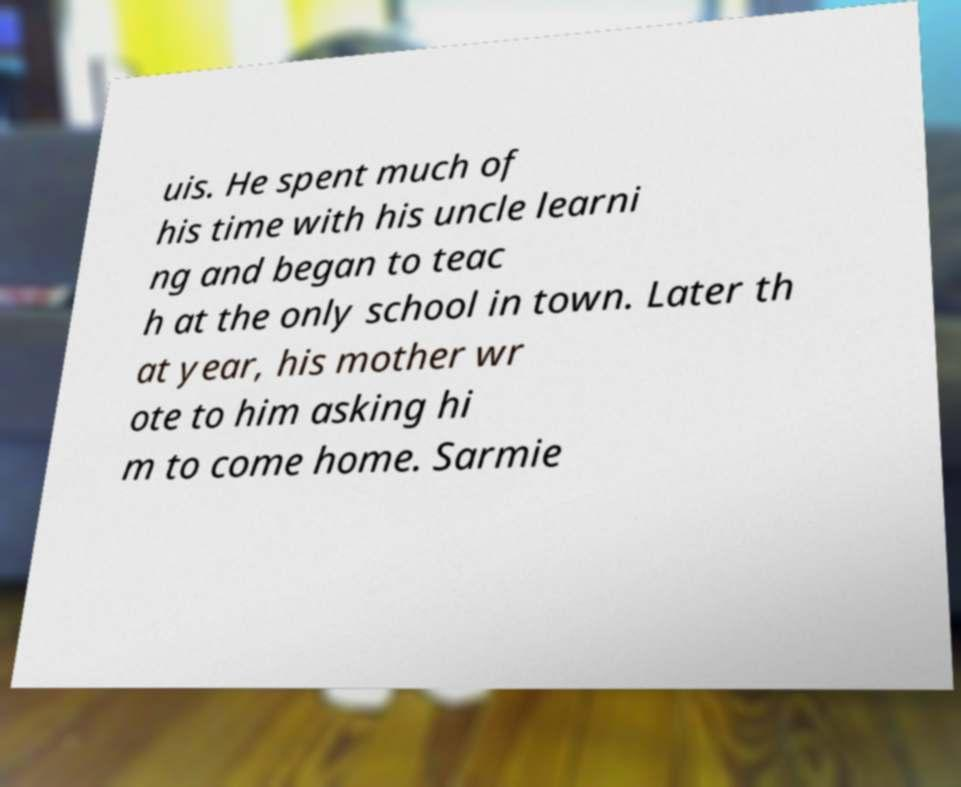There's text embedded in this image that I need extracted. Can you transcribe it verbatim? uis. He spent much of his time with his uncle learni ng and began to teac h at the only school in town. Later th at year, his mother wr ote to him asking hi m to come home. Sarmie 